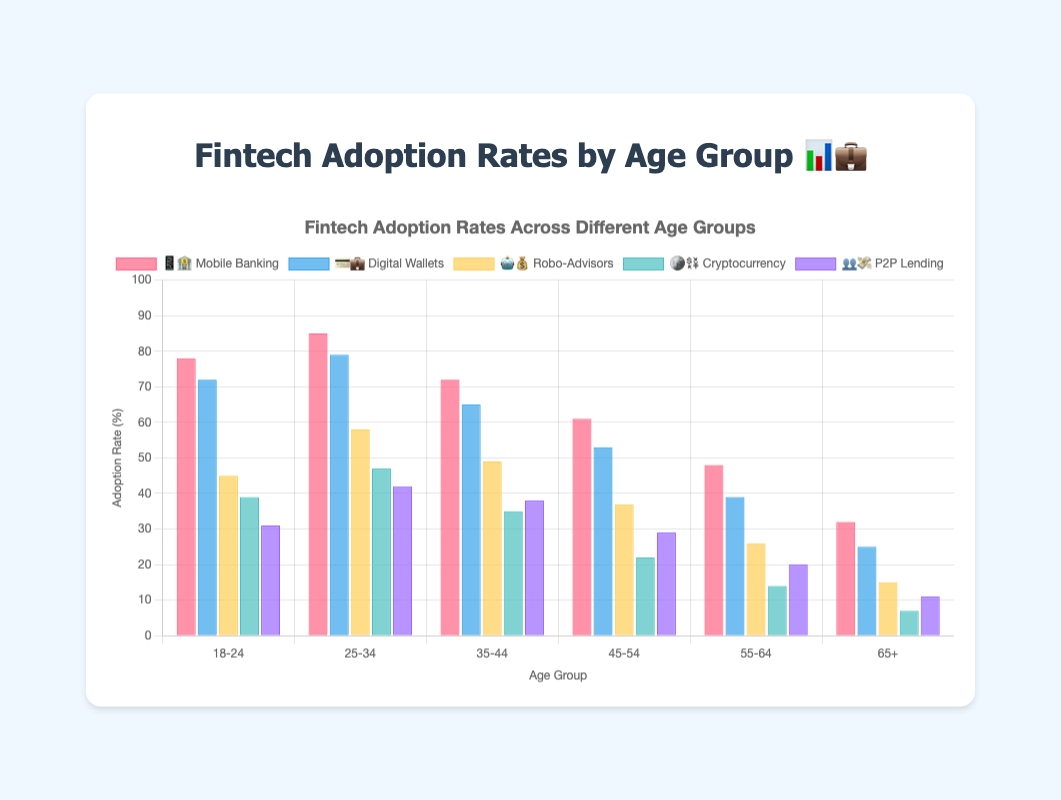Which age group has the highest adoption rate for Mobile Banking 📱🏦? The bar representing the 25-34 age group has the tallest height among those for Mobile Banking, indicating the highest adoption rate.
Answer: 25-34 What's the percentage difference between the adoption rates of Digital Wallets 💳💼 in the 18-24 and 65+ age groups? The adoption rate for Digital Wallets in the 18-24 age group is 72%, and in the 65+ age group, it is 25%. The difference is calculated as 72% - 25%.
Answer: 47% Among all the fintech solutions, which one shows the steepest decline in adoption rates as age increases? The chart shows that the bars for Cryptocurrency 🪙💱 drop the most sharply from the youngest to the oldest age groups, starting from 39% in the 18-24 group to 7% in the 65+ group.
Answer: Cryptocurrency For the age group 35-44, which fintech solution has the highest adoption rate? By looking at the bars for the 35-44 age group, the tallest bar corresponds to Mobile Banking 📱🏦.
Answer: Mobile Banking Compare the adoption rates of Robo-Advisors 🤖💰 and P2P Lending 👥💸 in the 55-64 age group. Which one is higher, and by how much? The adoption rate for Robo-Advisors in the 55-64 age group is 26%, and for P2P Lending, it is 20%. The difference is calculated as 26% - 20%.
Answer: Robo-Advisors, 6% What is the average adoption rate of Digital Wallets 💳💼 across all age groups? To find the average, sum the adoption rates for Digital Wallets across all age groups (72 + 79 + 65 + 53 + 39 + 25) and divide by the number of age groups, which is 6. The sum is 333, so the average is 333/6.
Answer: 55.5% In the 45-54 age group, which fintech solution has the second highest adoption rate? For the 45-54 age group, the bars show that Mobile Banking 📱🏦 has the highest adoption rate followed by Digital Wallets 💳💼.
Answer: Digital Wallets What is the total adoption rate for the 18-24 age group across all fintech solutions? Sum the adoption rates for all fintech solutions in the 18-24 age group: Mobile Banking (78) + Digital Wallets (72) + Robo-Advisors (45) + Cryptocurrency (39) + P2P Lending (31). The total is 78 + 72 + 45 + 39 + 31.
Answer: 265% Which fintech solution has the least variation in adoption rates across age groups? Observing the bars for each solution, Robo-Advisors 🤖💰 appear to have the least variation, with adoption rates ranging from 15% to 58%.
Answer: Robo-Advisors In the 65+ age group, which fintech solution shows an adoption rate of 32%? By examining the bars for the 65+ age group, the only fintech solution with an adoption rate of 32% is Mobile Banking 📱🏦.
Answer: Mobile Banking 